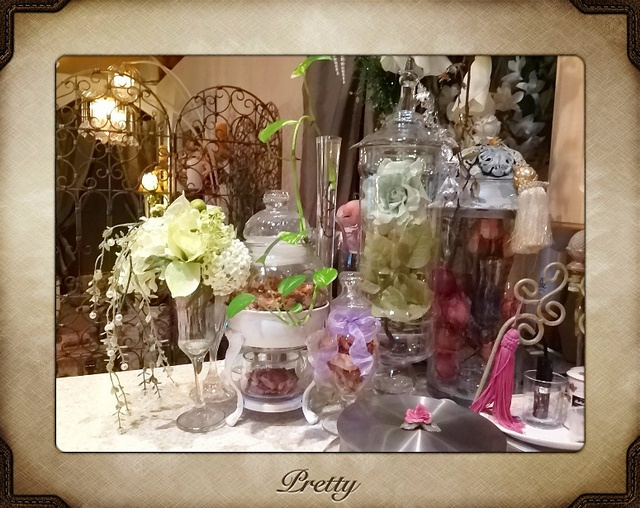Describe the objects in this image and their specific colors. I can see vase in black, gray, darkgray, and olive tones, vase in black, maroon, gray, and darkgray tones, vase in black, darkgray, maroon, and gray tones, wine glass in black, darkgray, olive, and gray tones, and vase in black, lightgray, darkgray, and tan tones in this image. 